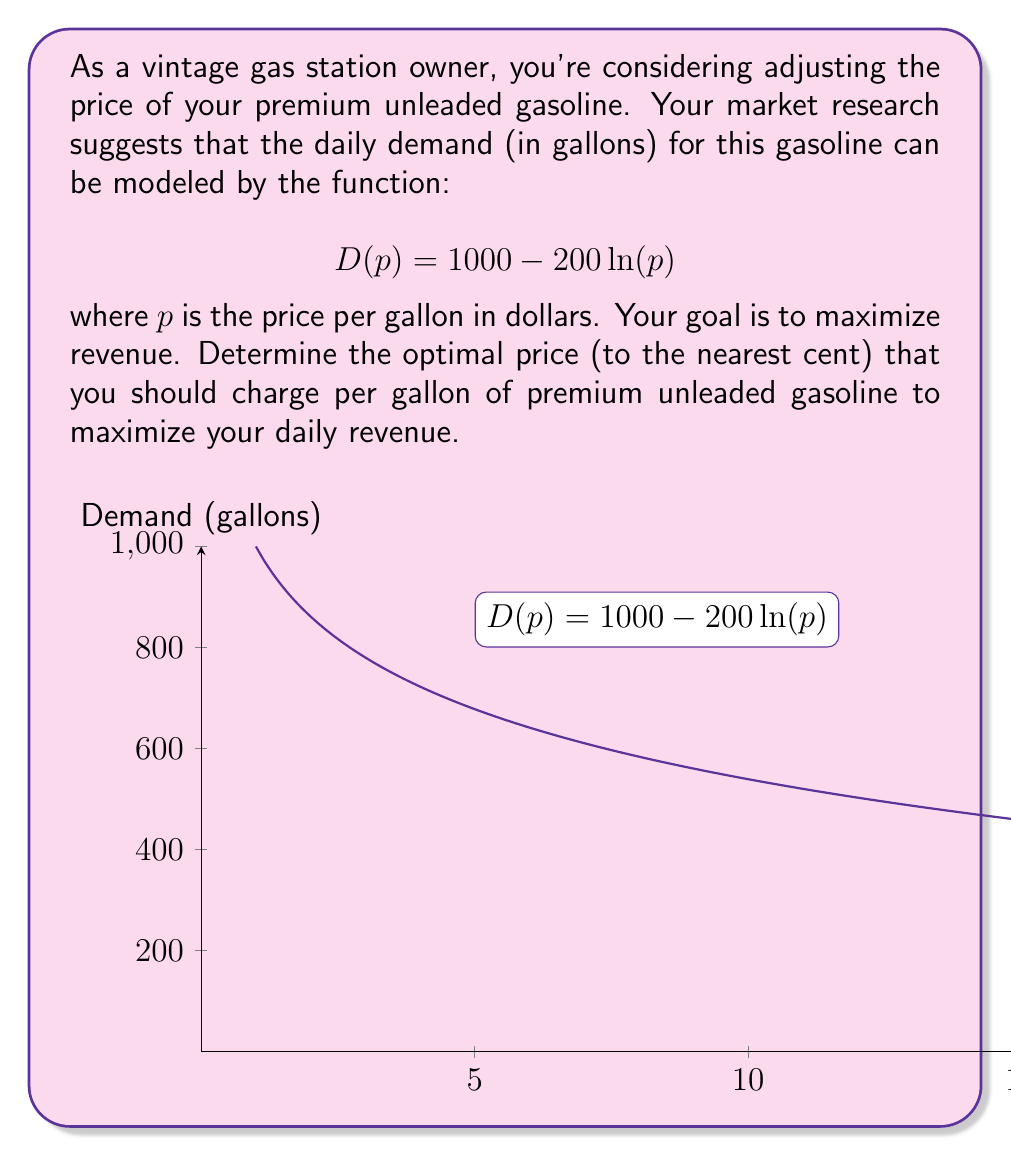Show me your answer to this math problem. Let's approach this step-by-step:

1) The revenue function $R(p)$ is the product of price and demand:
   $$R(p) = p \cdot D(p) = p(1000 - 200\ln(p))$$

2) To find the maximum revenue, we need to find where the derivative of $R(p)$ equals zero:
   $$\frac{dR}{dp} = 1000 - 200\ln(p) - 200 = 0$$

3) Simplify:
   $$800 - 200\ln(p) = 0$$

4) Divide both sides by 200:
   $$4 - \ln(p) = 0$$

5) Add $\ln(p)$ to both sides:
   $$4 = \ln(p)$$

6) Apply $e$ to both sides:
   $$e^4 = p$$

7) Calculate:
   $$p \approx 54.5982$$

8) Rounding to the nearest cent:
   $$p = $54.60$$

9) To confirm this is a maximum, we could check the second derivative is negative at this point (omitted for brevity).

Therefore, the optimal price to charge is $54.60 per gallon.
Answer: $54.60 per gallon 